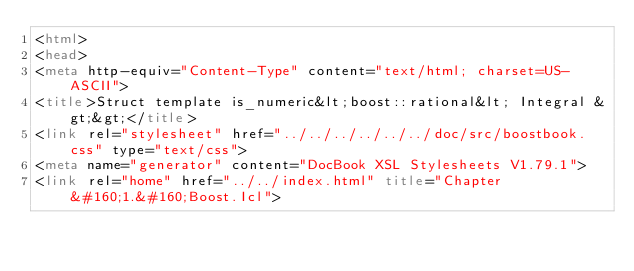Convert code to text. <code><loc_0><loc_0><loc_500><loc_500><_HTML_><html>
<head>
<meta http-equiv="Content-Type" content="text/html; charset=US-ASCII">
<title>Struct template is_numeric&lt;boost::rational&lt; Integral &gt;&gt;</title>
<link rel="stylesheet" href="../../../../../../doc/src/boostbook.css" type="text/css">
<meta name="generator" content="DocBook XSL Stylesheets V1.79.1">
<link rel="home" href="../../index.html" title="Chapter&#160;1.&#160;Boost.Icl"></code> 